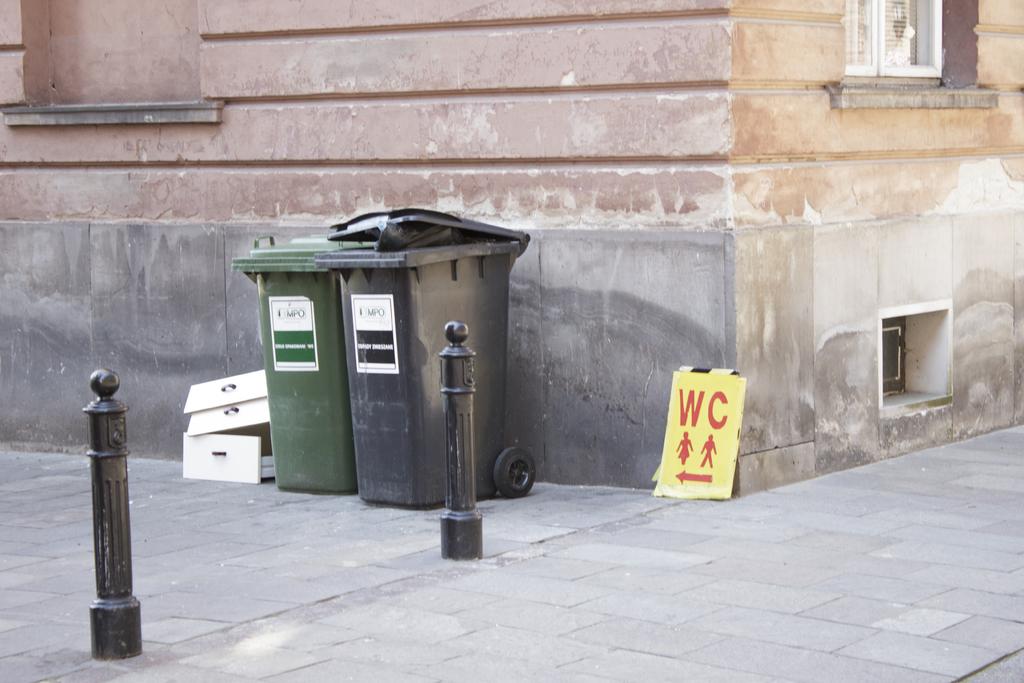What letters are on the yellow sign?
Provide a succinct answer. Wc. 